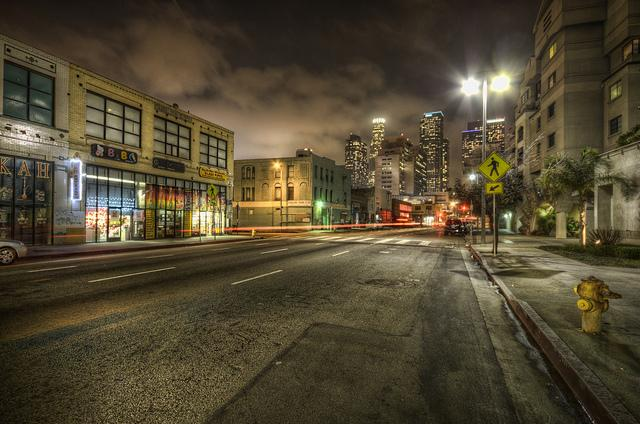What animal would you be most unlikely to see in this setting? bear 